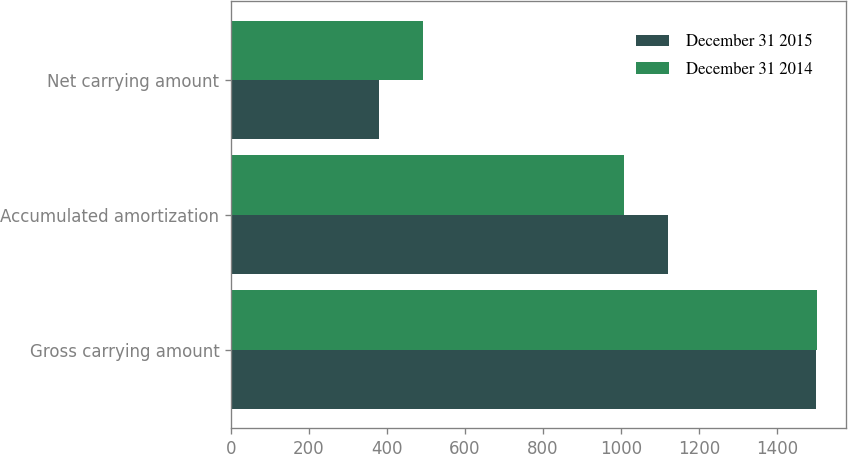Convert chart to OTSL. <chart><loc_0><loc_0><loc_500><loc_500><stacked_bar_chart><ecel><fcel>Gross carrying amount<fcel>Accumulated amortization<fcel>Net carrying amount<nl><fcel>December 31 2015<fcel>1499<fcel>1120<fcel>379<nl><fcel>December 31 2014<fcel>1502<fcel>1009<fcel>493<nl></chart> 